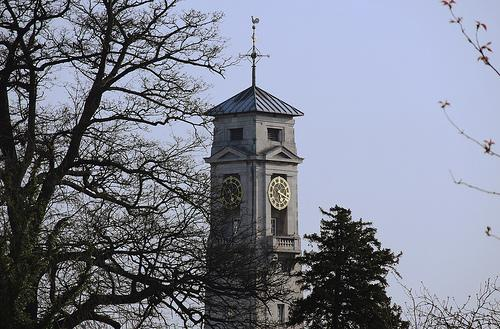Explain the position and design of the balcony on the clock tower. The small balcony is positioned on the tower's upper part, with a door and a rectangular window near the top. Mention the architectural details of the clock tower. The clock tower has a blue triangular roof, gold clocks on either side, a small balcony, a rooster weather vane, and a window at the top. Describe the elements of nature present in the scene. There are large trees, clear light blue sky, and bare branches of the brown tree. Describe the surroundings of the main subject in the picture. Large trees with and without leaves are near the clock tower, under a light blue sky with no clouds. State the time indication on the clock tower and its design. The round clock on the tower, having a white face and gold dials, indicates around 4:20 or 5:18 PM. Provide a brief description of the overall scene in the image. A stone clock tower stands tall near trees with a clear blue sky in the background; the tower features a blue roof and gold dials. Highlight the features of the clock on the tower. The clock is round, with a white face and gold dials, positioned on either side of the tower. Write about the weather condition in the image. The sky is clear with a light blue hue, indicating a sunny day with no clouds. Mention the major object in the image and its key features. A tall gray clock tower with a blue metal roof, gold clocks on either side, a balcony, and a decorative rod with a rooster on top. Mention the trees seen in the vicinity of the clock tower. A large tree with no leaves and a small green pine tree can be seen nearby, as well as a tall green tree with branches. 